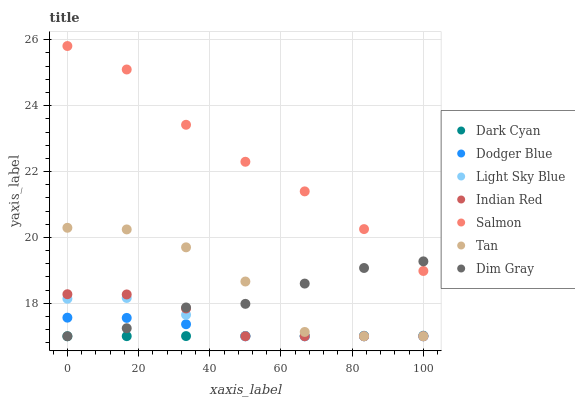Does Dark Cyan have the minimum area under the curve?
Answer yes or no. Yes. Does Salmon have the maximum area under the curve?
Answer yes or no. Yes. Does Light Sky Blue have the minimum area under the curve?
Answer yes or no. No. Does Light Sky Blue have the maximum area under the curve?
Answer yes or no. No. Is Dark Cyan the smoothest?
Answer yes or no. Yes. Is Tan the roughest?
Answer yes or no. Yes. Is Salmon the smoothest?
Answer yes or no. No. Is Salmon the roughest?
Answer yes or no. No. Does Dim Gray have the lowest value?
Answer yes or no. Yes. Does Salmon have the lowest value?
Answer yes or no. No. Does Salmon have the highest value?
Answer yes or no. Yes. Does Light Sky Blue have the highest value?
Answer yes or no. No. Is Tan less than Salmon?
Answer yes or no. Yes. Is Salmon greater than Light Sky Blue?
Answer yes or no. Yes. Does Dodger Blue intersect Dark Cyan?
Answer yes or no. Yes. Is Dodger Blue less than Dark Cyan?
Answer yes or no. No. Is Dodger Blue greater than Dark Cyan?
Answer yes or no. No. Does Tan intersect Salmon?
Answer yes or no. No. 